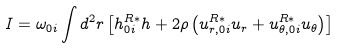Convert formula to latex. <formula><loc_0><loc_0><loc_500><loc_500>I = \omega _ { 0 i } \int d ^ { 2 } r \left [ h ^ { R \ast } _ { 0 i } h + 2 \rho \left ( u ^ { R \ast } _ { r , 0 i } u _ { r } + u ^ { R \ast } _ { \theta , 0 i } u _ { \theta } \right ) \right ]</formula> 